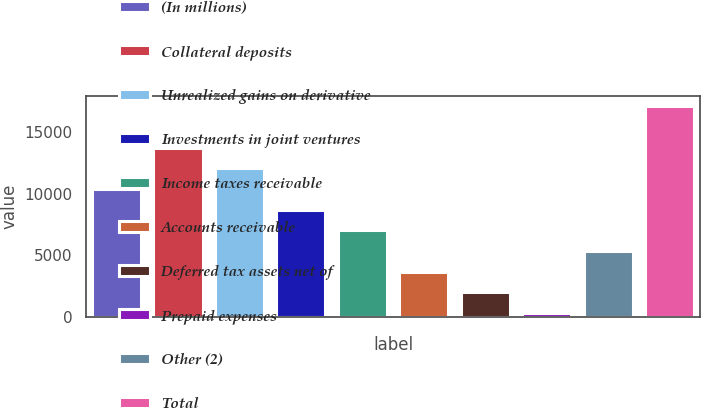<chart> <loc_0><loc_0><loc_500><loc_500><bar_chart><fcel>(In millions)<fcel>Collateral deposits<fcel>Unrealized gains on derivative<fcel>Investments in joint ventures<fcel>Income taxes receivable<fcel>Accounts receivable<fcel>Deferred tax assets net of<fcel>Prepaid expenses<fcel>Other (2)<fcel>Total<nl><fcel>10406.6<fcel>13772.8<fcel>12089.7<fcel>8723.5<fcel>7040.4<fcel>3674.2<fcel>1991.1<fcel>308<fcel>5357.3<fcel>17139<nl></chart> 